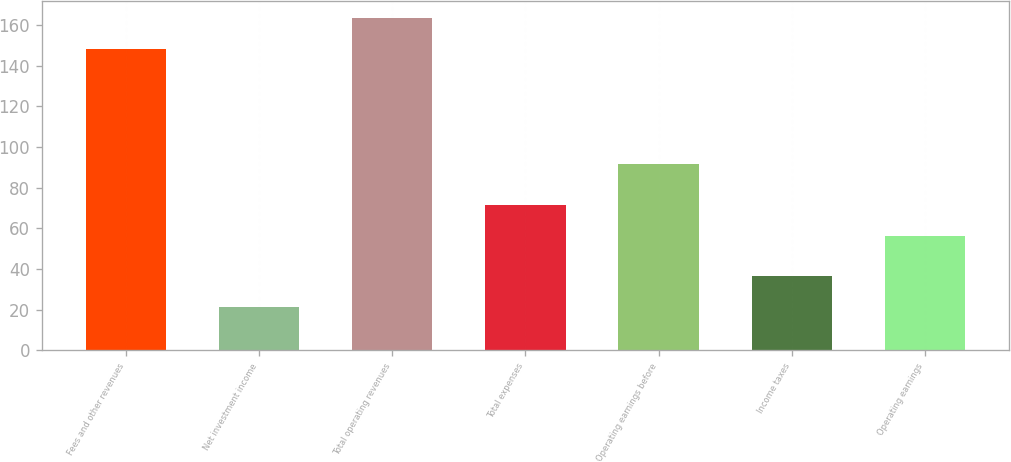Convert chart. <chart><loc_0><loc_0><loc_500><loc_500><bar_chart><fcel>Fees and other revenues<fcel>Net investment income<fcel>Total operating revenues<fcel>Total expenses<fcel>Operating earnings before<fcel>Income taxes<fcel>Operating earnings<nl><fcel>148.1<fcel>21.04<fcel>163.44<fcel>71.54<fcel>91.8<fcel>36.38<fcel>56.2<nl></chart> 